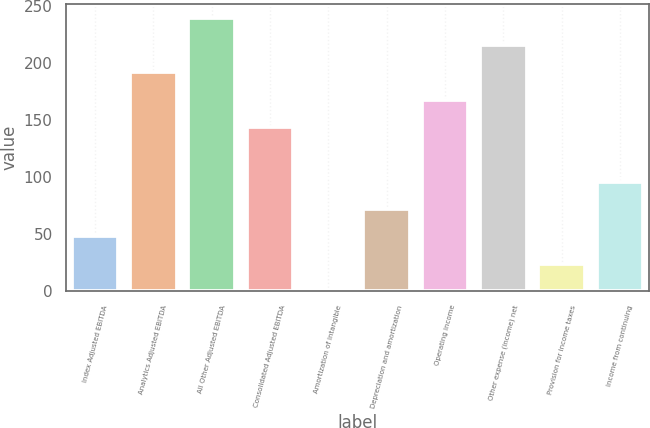Convert chart to OTSL. <chart><loc_0><loc_0><loc_500><loc_500><bar_chart><fcel>Index Adjusted EBITDA<fcel>Analytics Adjusted EBITDA<fcel>All Other Adjusted EBITDA<fcel>Consolidated Adjusted EBITDA<fcel>Amortization of intangible<fcel>Depreciation and amortization<fcel>Operating income<fcel>Other expense (income) net<fcel>Provision for income taxes<fcel>Income from continuing<nl><fcel>48.28<fcel>192.22<fcel>240.2<fcel>144.24<fcel>0.3<fcel>72.27<fcel>168.23<fcel>216.21<fcel>24.29<fcel>96.26<nl></chart> 